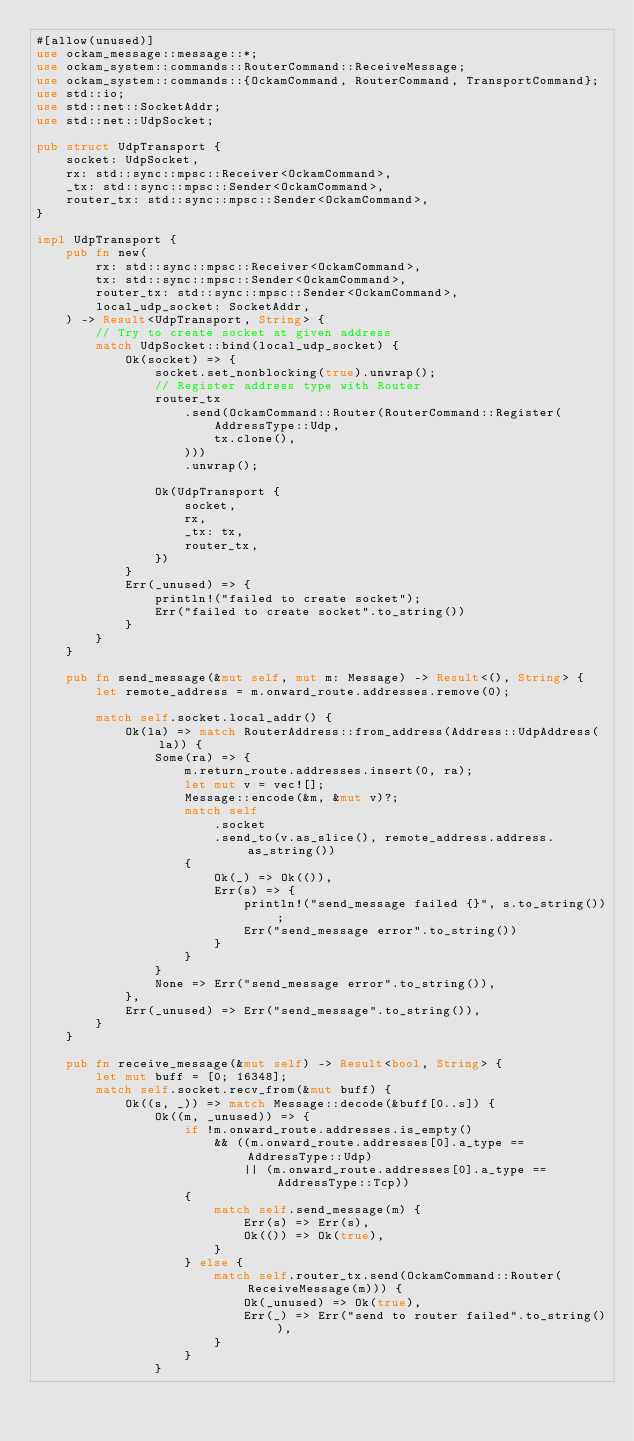<code> <loc_0><loc_0><loc_500><loc_500><_Rust_>#[allow(unused)]
use ockam_message::message::*;
use ockam_system::commands::RouterCommand::ReceiveMessage;
use ockam_system::commands::{OckamCommand, RouterCommand, TransportCommand};
use std::io;
use std::net::SocketAddr;
use std::net::UdpSocket;

pub struct UdpTransport {
    socket: UdpSocket,
    rx: std::sync::mpsc::Receiver<OckamCommand>,
    _tx: std::sync::mpsc::Sender<OckamCommand>,
    router_tx: std::sync::mpsc::Sender<OckamCommand>,
}

impl UdpTransport {
    pub fn new(
        rx: std::sync::mpsc::Receiver<OckamCommand>,
        tx: std::sync::mpsc::Sender<OckamCommand>,
        router_tx: std::sync::mpsc::Sender<OckamCommand>,
        local_udp_socket: SocketAddr,
    ) -> Result<UdpTransport, String> {
        // Try to create socket at given address
        match UdpSocket::bind(local_udp_socket) {
            Ok(socket) => {
                socket.set_nonblocking(true).unwrap();
                // Register address type with Router
                router_tx
                    .send(OckamCommand::Router(RouterCommand::Register(
                        AddressType::Udp,
                        tx.clone(),
                    )))
                    .unwrap();

                Ok(UdpTransport {
                    socket,
                    rx,
                    _tx: tx,
                    router_tx,
                })
            }
            Err(_unused) => {
                println!("failed to create socket");
                Err("failed to create socket".to_string())
            }
        }
    }

    pub fn send_message(&mut self, mut m: Message) -> Result<(), String> {
        let remote_address = m.onward_route.addresses.remove(0);

        match self.socket.local_addr() {
            Ok(la) => match RouterAddress::from_address(Address::UdpAddress(la)) {
                Some(ra) => {
                    m.return_route.addresses.insert(0, ra);
                    let mut v = vec![];
                    Message::encode(&m, &mut v)?;
                    match self
                        .socket
                        .send_to(v.as_slice(), remote_address.address.as_string())
                    {
                        Ok(_) => Ok(()),
                        Err(s) => {
                            println!("send_message failed {}", s.to_string());
                            Err("send_message error".to_string())
                        }
                    }
                }
                None => Err("send_message error".to_string()),
            },
            Err(_unused) => Err("send_message".to_string()),
        }
    }

    pub fn receive_message(&mut self) -> Result<bool, String> {
        let mut buff = [0; 16348];
        match self.socket.recv_from(&mut buff) {
            Ok((s, _)) => match Message::decode(&buff[0..s]) {
                Ok((m, _unused)) => {
                    if !m.onward_route.addresses.is_empty()
                        && ((m.onward_route.addresses[0].a_type == AddressType::Udp)
                            || (m.onward_route.addresses[0].a_type == AddressType::Tcp))
                    {
                        match self.send_message(m) {
                            Err(s) => Err(s),
                            Ok(()) => Ok(true),
                        }
                    } else {
                        match self.router_tx.send(OckamCommand::Router(ReceiveMessage(m))) {
                            Ok(_unused) => Ok(true),
                            Err(_) => Err("send to router failed".to_string()),
                        }
                    }
                }</code> 